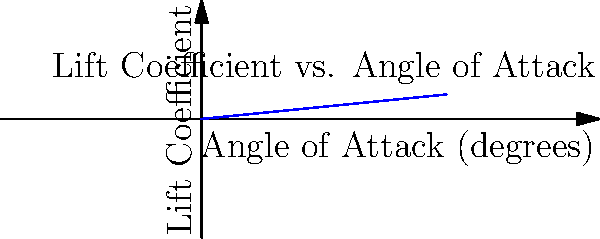A hang glider is being used for sightseeing in the Dinaric Alps. The graph shows the relationship between the lift coefficient and the angle of attack for the hang glider. If the optimal lift coefficient for stable flight in the mountain air currents is 0.6, what is the approximate angle of attack the pilot should maintain? To find the optimal angle of attack, we need to follow these steps:

1. Understand the graph:
   - The x-axis represents the angle of attack in degrees.
   - The y-axis represents the lift coefficient.
   - The blue line shows the relationship between these two variables.

2. Identify the target lift coefficient:
   - The optimal lift coefficient for stable flight is given as 0.6.

3. Locate the point on the graph:
   - Find where the lift coefficient (y-axis) is 0.6.

4. Read the corresponding angle of attack:
   - Draw an imaginary horizontal line from 0.6 on the y-axis to the blue line.
   - From that intersection, draw an imaginary vertical line down to the x-axis.

5. Interpret the result:
   - The point where the vertical line meets the x-axis is approximately 6 degrees.

Therefore, the pilot should maintain an angle of attack of about 6 degrees for optimal lift in the mountain air currents.
Answer: 6 degrees 